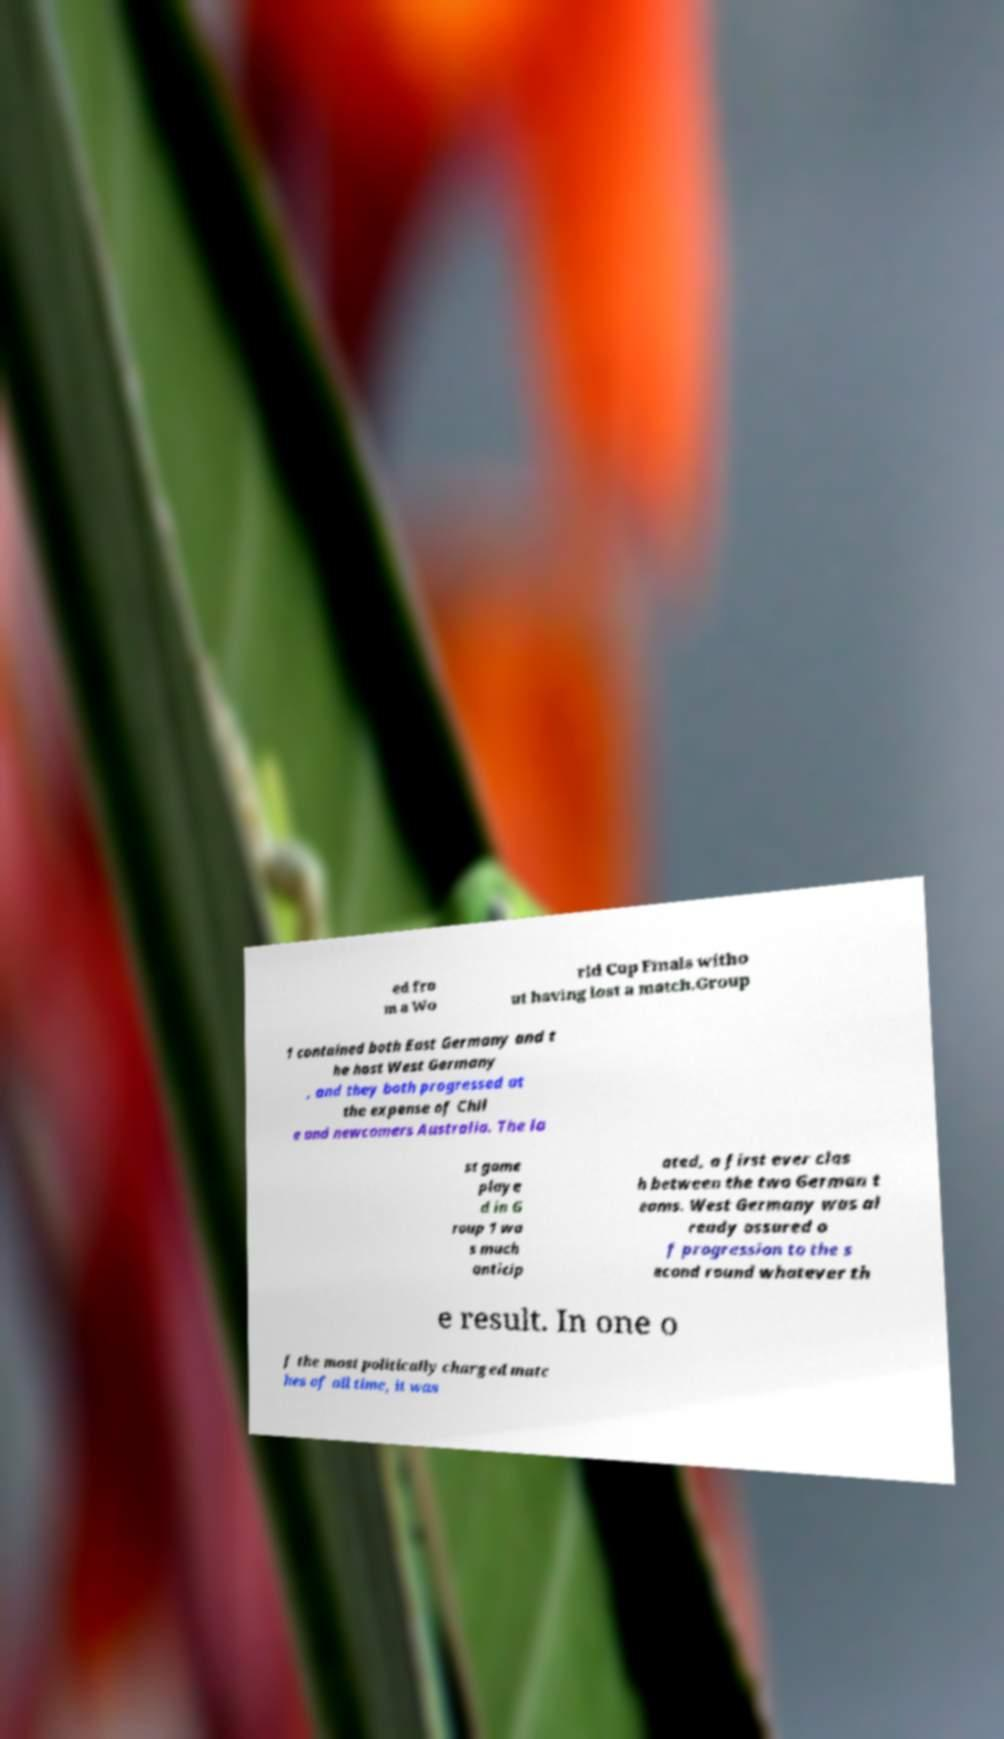Could you extract and type out the text from this image? ed fro m a Wo rld Cup Finals witho ut having lost a match.Group 1 contained both East Germany and t he host West Germany , and they both progressed at the expense of Chil e and newcomers Australia. The la st game playe d in G roup 1 wa s much anticip ated, a first ever clas h between the two German t eams. West Germany was al ready assured o f progression to the s econd round whatever th e result. In one o f the most politically charged matc hes of all time, it was 